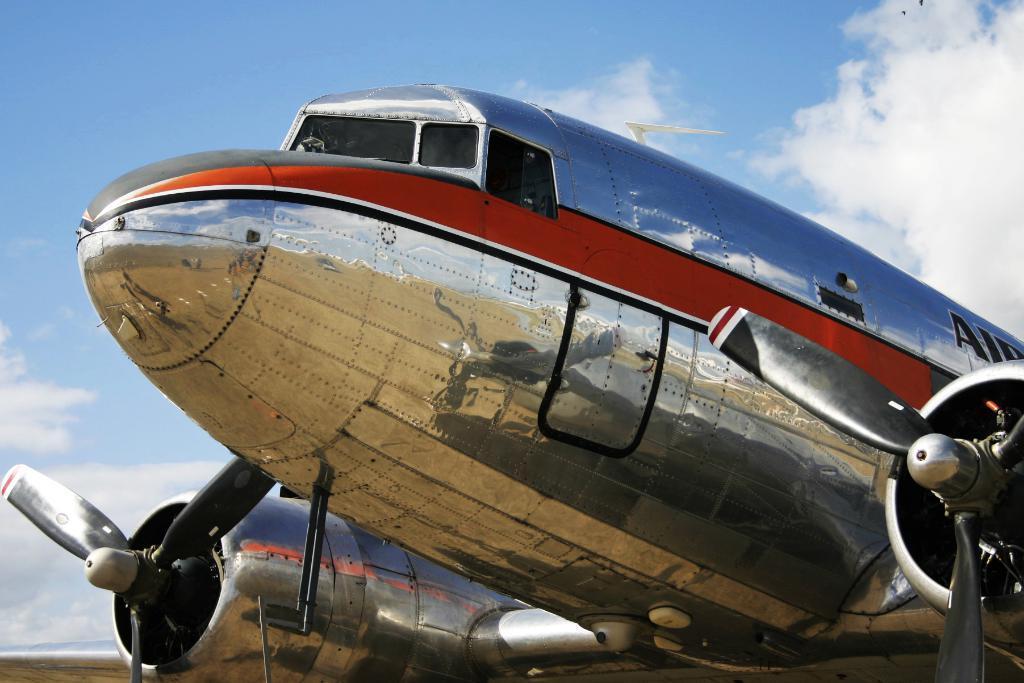Can you describe this image briefly? In this image in the front there is an airplane with some text written on it. In the background the sky is cloudy. 